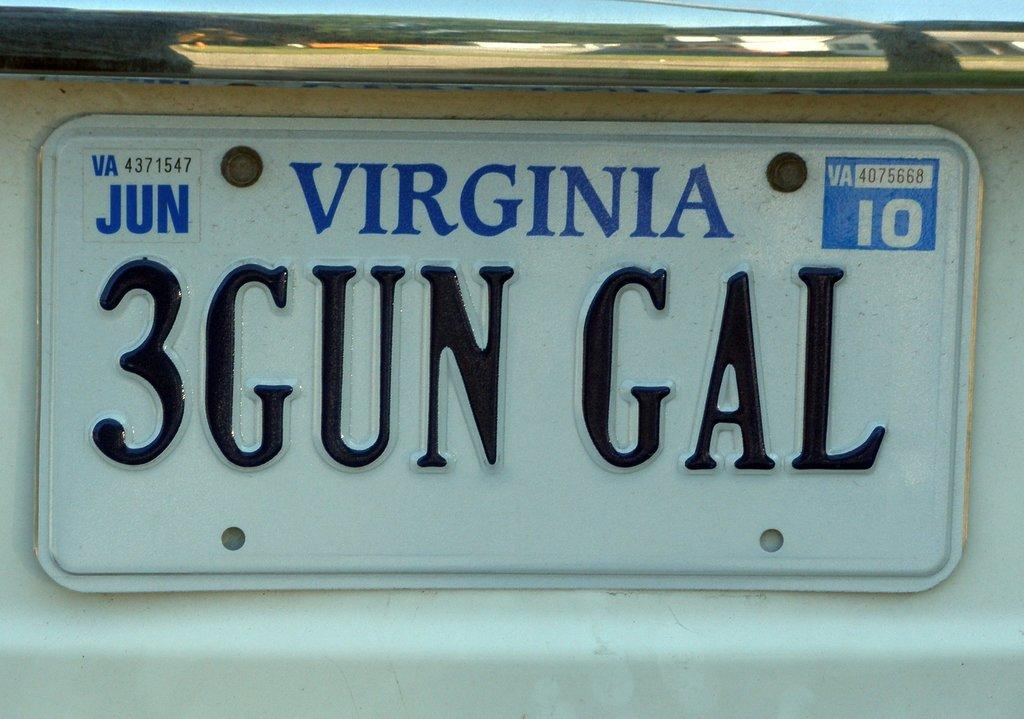<image>
Give a short and clear explanation of the subsequent image. white vehicle with virginia tags 3GUN GAL that expires in june 2010 